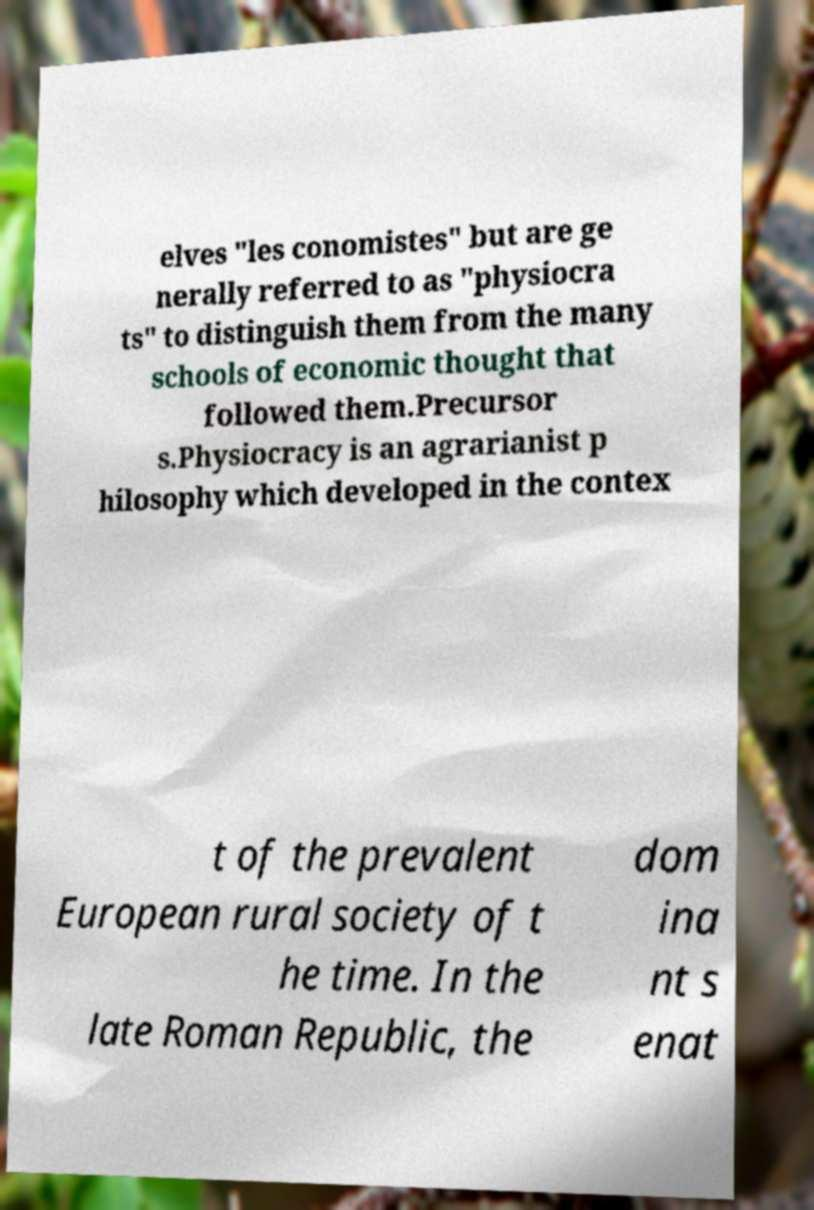Could you extract and type out the text from this image? elves "les conomistes" but are ge nerally referred to as "physiocra ts" to distinguish them from the many schools of economic thought that followed them.Precursor s.Physiocracy is an agrarianist p hilosophy which developed in the contex t of the prevalent European rural society of t he time. In the late Roman Republic, the dom ina nt s enat 